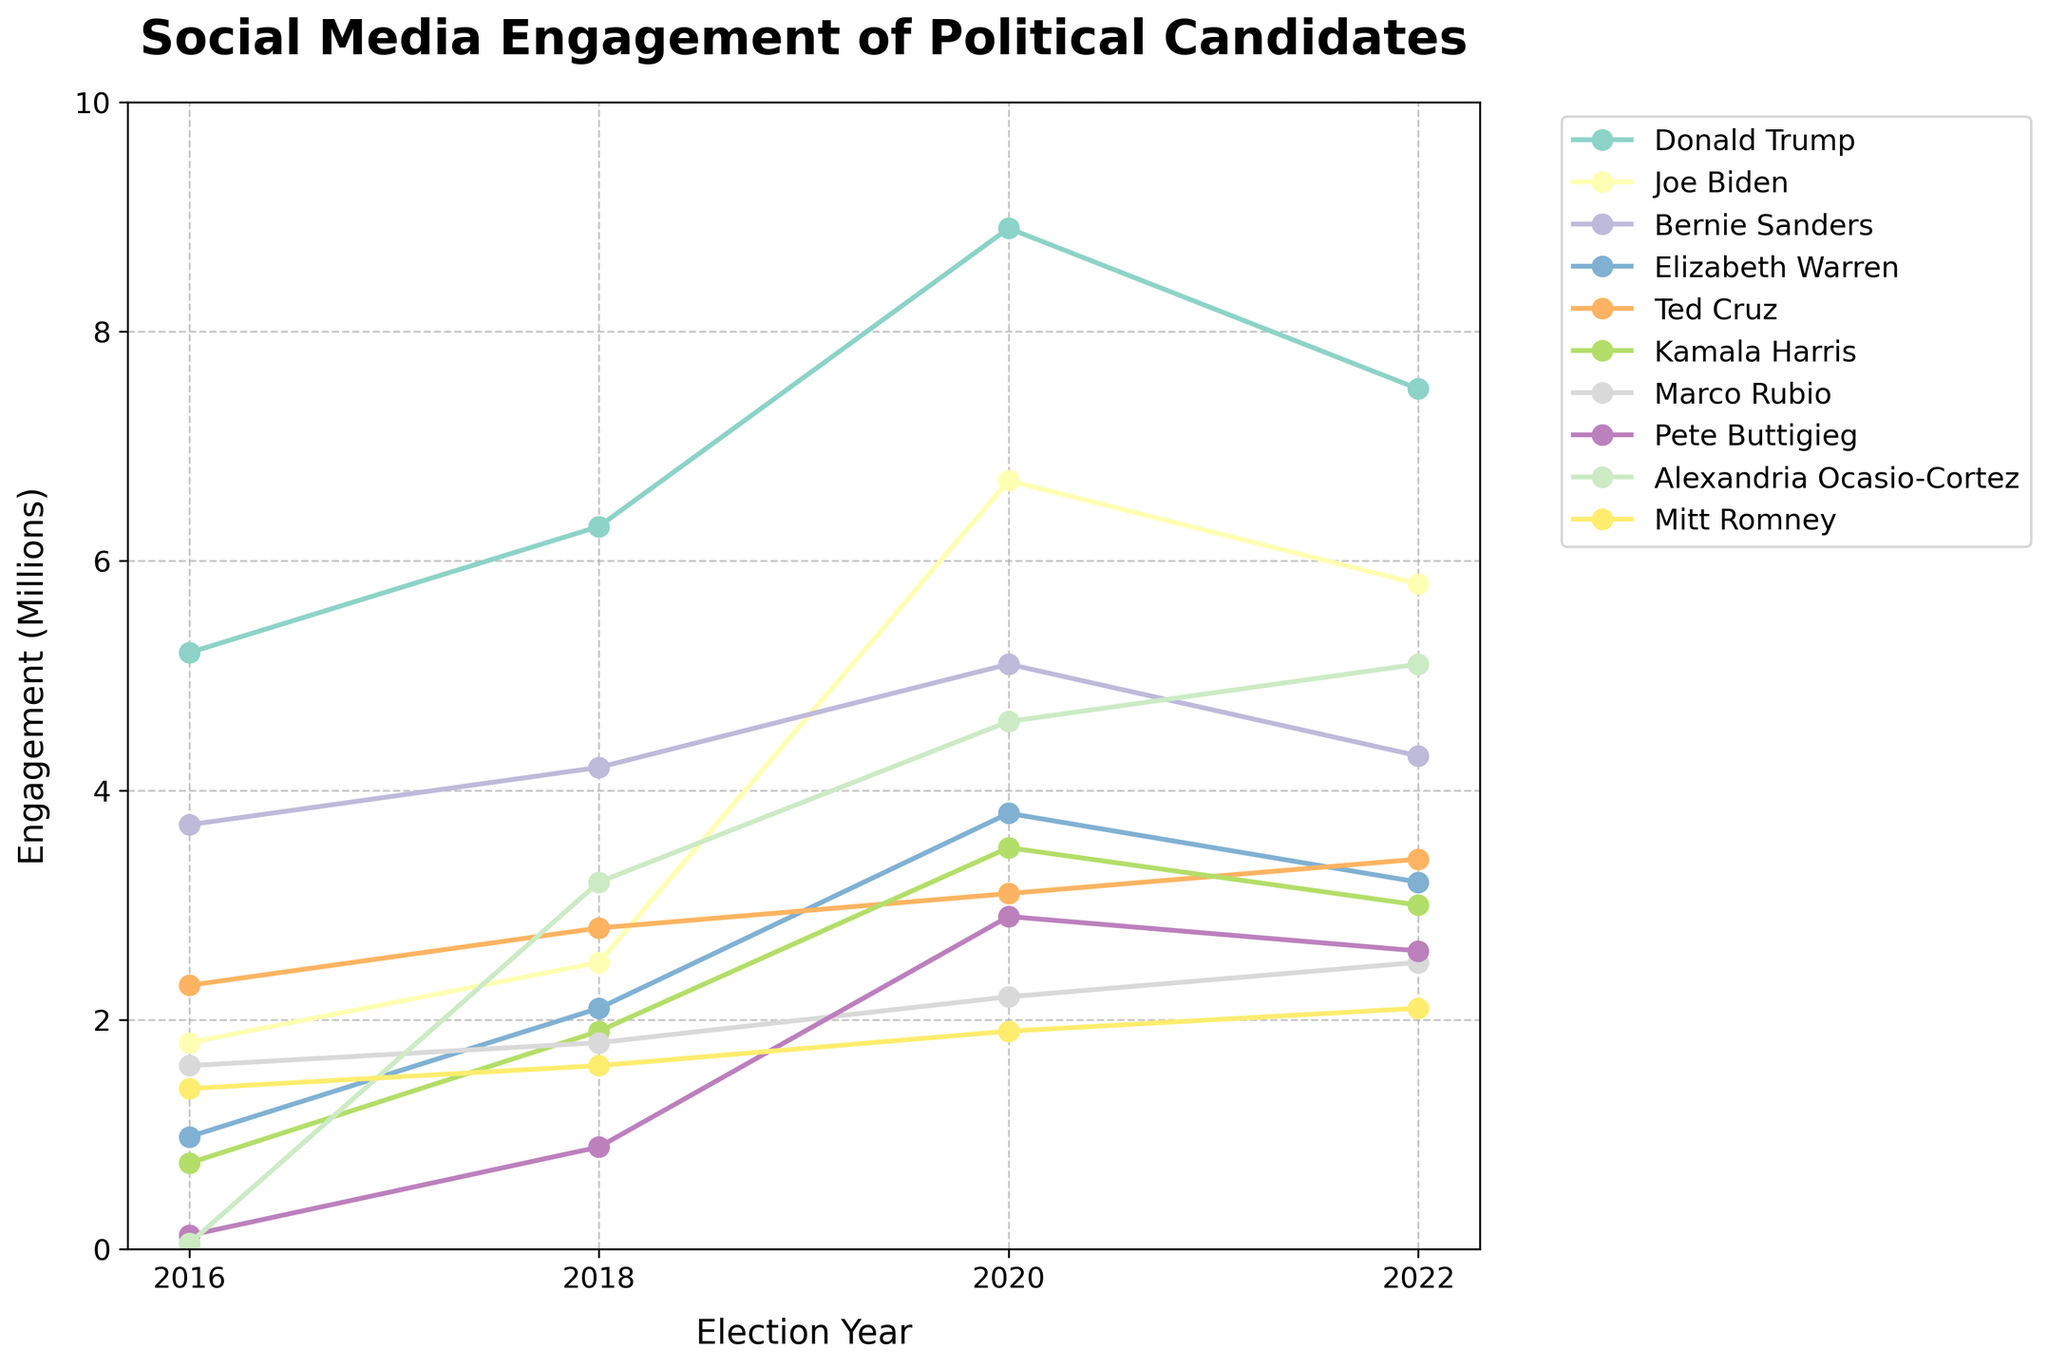Which candidate had the highest social media engagement in 2020? To find the candidate with the highest social media engagement in 2020, look at the values for each candidate under the 2020 column and identify the largest number. Donald Trump's value is the largest.
Answer: Donald Trump What is the average social media engagement for Bernie Sanders across the four election years? To find the average, sum Bernie Sanders’s engagements for the years 2016, 2018, 2020, and 2022, then divide by 4. The sum is 3,700,000 + 4,200,000 + 5,100,000 + 4,300,000 = 17,300,000. Divide by 4 to get 4,325,000.
Answer: 4,325,000 Which candidate had a higher increase in social media engagement from 2018 to 2020, Joe Biden or Elizabeth Warren? Compare Joe Biden's increase (6,700,000 - 2,500,000 = 4,200,000) and Elizabeth Warren’s increase (3,800,000 - 2,100,000 = 1,700,000) from 2018 to 2020. Joe Biden had a higher increase.
Answer: Joe Biden How much did Kamala Harris's social media engagement increase from 2016 to 2020? Subtract Kamala Harris's 2016 engagement from her 2020 engagement. 3,500,000 - 750,000 = 2,750,000.
Answer: 2,750,000 Which candidate had the smallest increase in social media engagement between any two consecutive election years? Examine all two-year intervals and calculate the increase for each candidate. Marco Rubio had the smallest increase from 2016 to 2018: 1,800,000 - 1,600,000 = 200,000.
Answer: Marco Rubio By how much did Alexandria Ocasio-Cortez's social media engagement change between 2016 and 2022? Subtract Alexandria Ocasio-Cortez's 2016 engagement from her 2022 engagement. 5,100,000 - 50,000 = 5,050,000.
Answer: 5,050,000 Which year saw the largest decrease in social media engagement for Donald Trump compared to the previous cycle? Compare Trump’s engagements between consecutive years: (2016 to 2018, 5,200,000 to 6,300,000: increase of 1,100,000), (2018 to 2020, 6,300,000 to 8,900,000: increase of 2,600,000), and (2020 to 2022, 8,900,000 to 7,500,000: decrease of 1,400,000). The largest decrease is from 2020 to 2022 by 1,400,000.
Answer: 2020 to 2022 What is the total social media engagement for Marco Rubio over all four election years? Sum Marco Rubio's engagements for 2016, 2018, 2020, and 2022: 1,600,000 + 1,800,000 + 2,200,000 + 2,500,000 = 8,100,000.
Answer: 8,100,000 How does the 2016 social media engagement of Ted Cruz compare to that of Mitt Romney? Compare Ted Cruz's 2016 engagement (2,300,000) with Mitt Romney’s 2016 engagement (1,400,000). Ted Cruz's engagement is higher.
Answer: Ted Cruz Which candidate saw a decline in social media engagement from 2020 to 2022, and how significant was it? Look for candidates with lower 2022 engagement compared to 2020. Donald Trump declined from 8,900,000 to 7,500,000, Joe Biden declined from 6,700,000 to 5,800,000, Bernie Sanders from 5,100,000 to 4,300,000, Elizabeth Warren from 3,800,000 to 3,200,000, and Kamala Harris from 3,500,000 to 3,000,000. Donald Trump's decline is the largest at 1,400,000.
Answer: Donald Trump, 1,400,000 